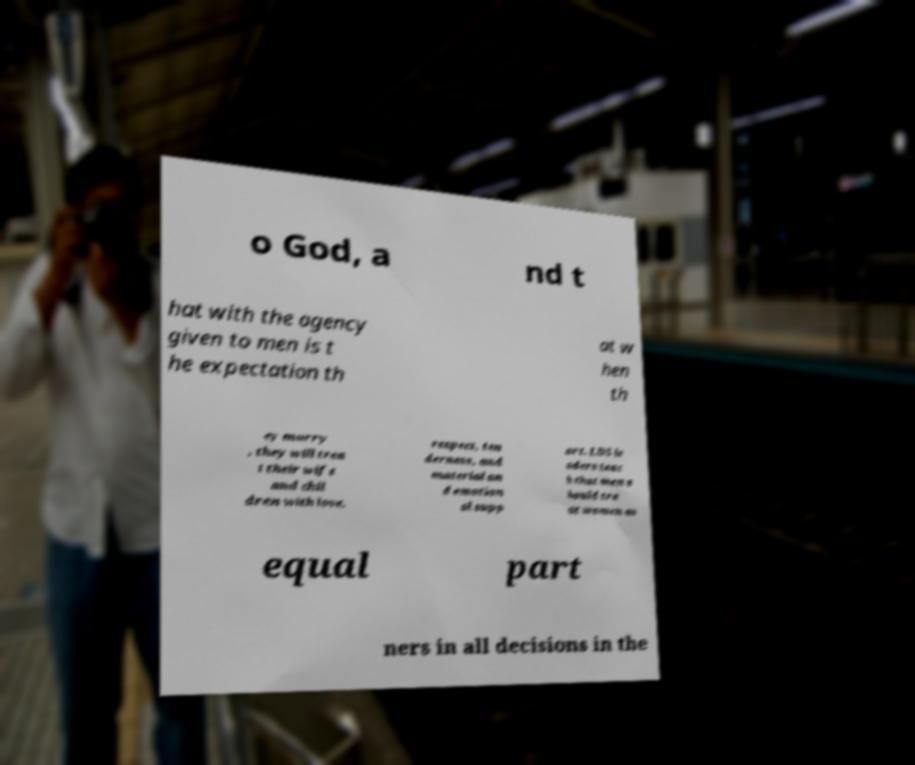What messages or text are displayed in this image? I need them in a readable, typed format. o God, a nd t hat with the agency given to men is t he expectation th at w hen th ey marry , they will trea t their wife and chil dren with love, respect, ten derness, and material an d emotion al supp ort. LDS le aders teac h that men s hould tre at women as equal part ners in all decisions in the 